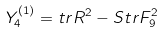Convert formula to latex. <formula><loc_0><loc_0><loc_500><loc_500>Y _ { 4 } ^ { ( 1 ) } = t r R ^ { 2 } - S t r F _ { 9 } ^ { 2 }</formula> 